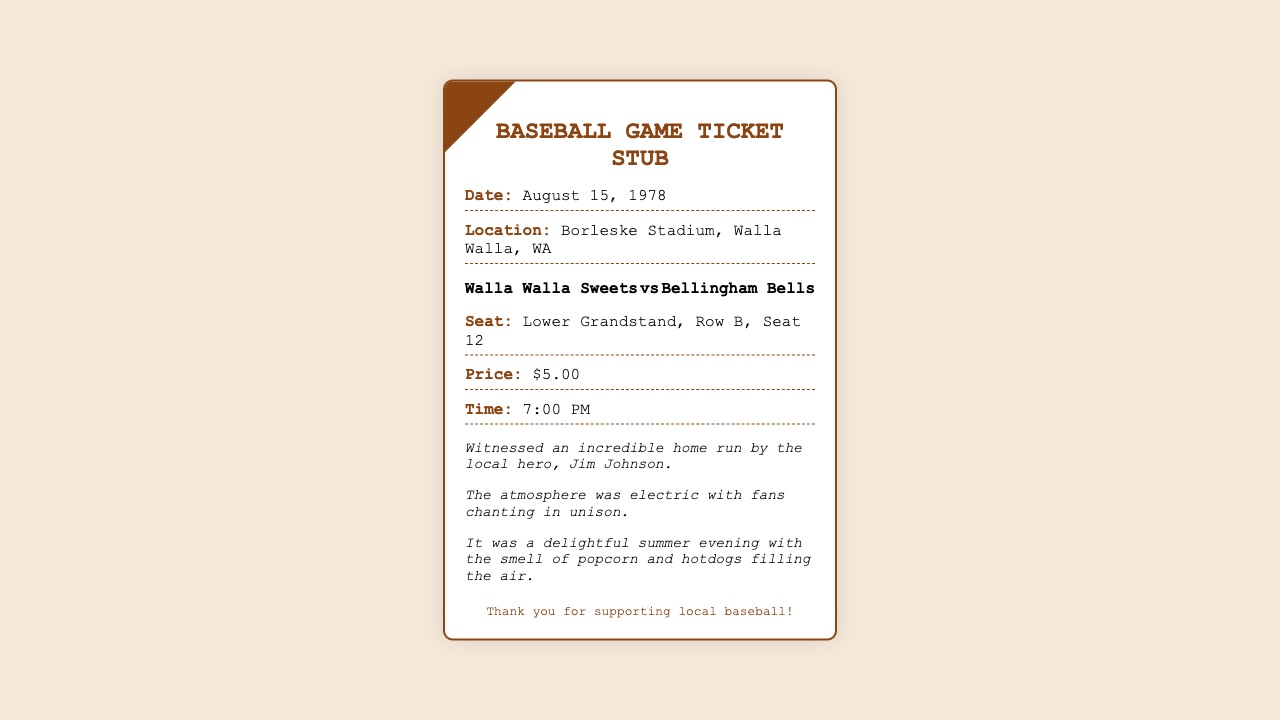What is the date of the game? The date of the game is clearly stated in the document under the date section.
Answer: August 15, 1978 Where is the game taking place? The location of the game is provided in the document, indicating the venue.
Answer: Borleske Stadium, Walla Walla, WA Who are the teams playing? The teams are listed prominently in the teams section of the document.
Answer: Walla Walla Sweets vs Bellingham Bells What is the seat location? The seat location is specified in the document under the seat info.
Answer: Lower Grandstand, Row B, Seat 12 What time does the game start? The time is mentioned in the document, indicating when the game begins.
Answer: 7:00 PM What was the ticket price? The price of the ticket is stated in the document.
Answer: $5.00 What memorable moment is mentioned? One of the memorable moments includes a specific event recalled in the memories section of the document.
Answer: An incredible home run by the local hero, Jim Johnson What kind of atmosphere is described? The atmosphere is described in the memorable moments section, reflecting the fans' reactions.
Answer: Electric with fans chanting in unison What is the note at the bottom of the stub? The notes section provides a concluding remark for the ticket stub.
Answer: Thank you for supporting local baseball! 